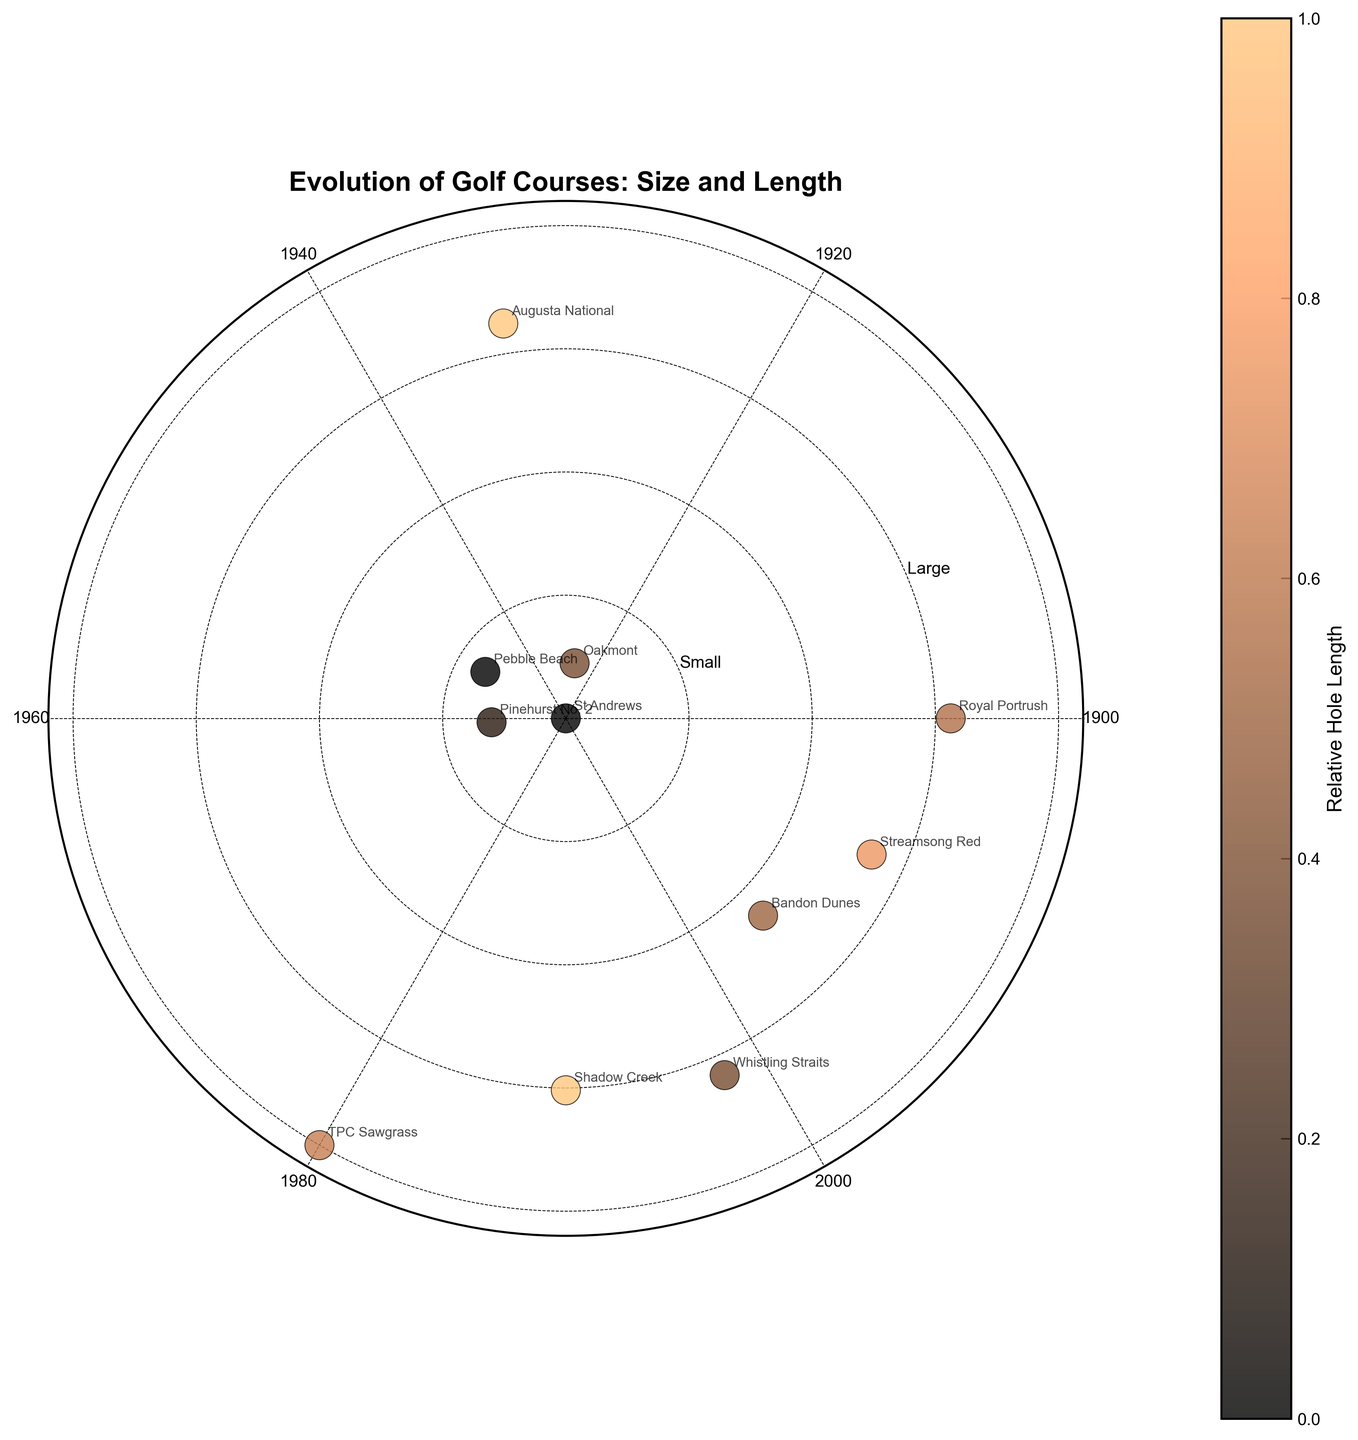What is the title of the figure? The title is clearly displayed at the top of the figure in bold font.
Answer: Evolution of Golf Courses: Size and Length How many data points are in the figure? Each course is represented by a single data point; counting them gives the total number.
Answer: 11 Which course has the largest size in acres? The size of each course is represented by the radial distance from the center. The largest radial distance corresponds to the largest size.
Answer: TPC Sawgrass What do the colors of the data points represent? The color gradient represents the relative length of the average hole, as indicated by the colorbar on the side.
Answer: Relative Hole Length Which course is closest to the year 2000 on the plot? Courses are distributed along the circumference based on their year of establishment. The closest data point to the year 2000 on the polar axis represents this.
Answer: Whistling Straits Are there more courses with small sizes or large sizes? The radial axis has labels indicating sizes from small to large. Count the number of points in each category.
Answer: More courses have large sizes Arrange the courses from the shortest to the longest average hole length. The color of the data points corresponds to the average hole length. Darker points indicate longer lengths.
Answer: St Andrews, Pebble Beach, Pinehurst No. 2, Whistling Straits, Bandon Dunes, Royal Portrush, Streamsong Red, TPC Sawgrass, Oakmont, Shadow Creek, Augusta National 